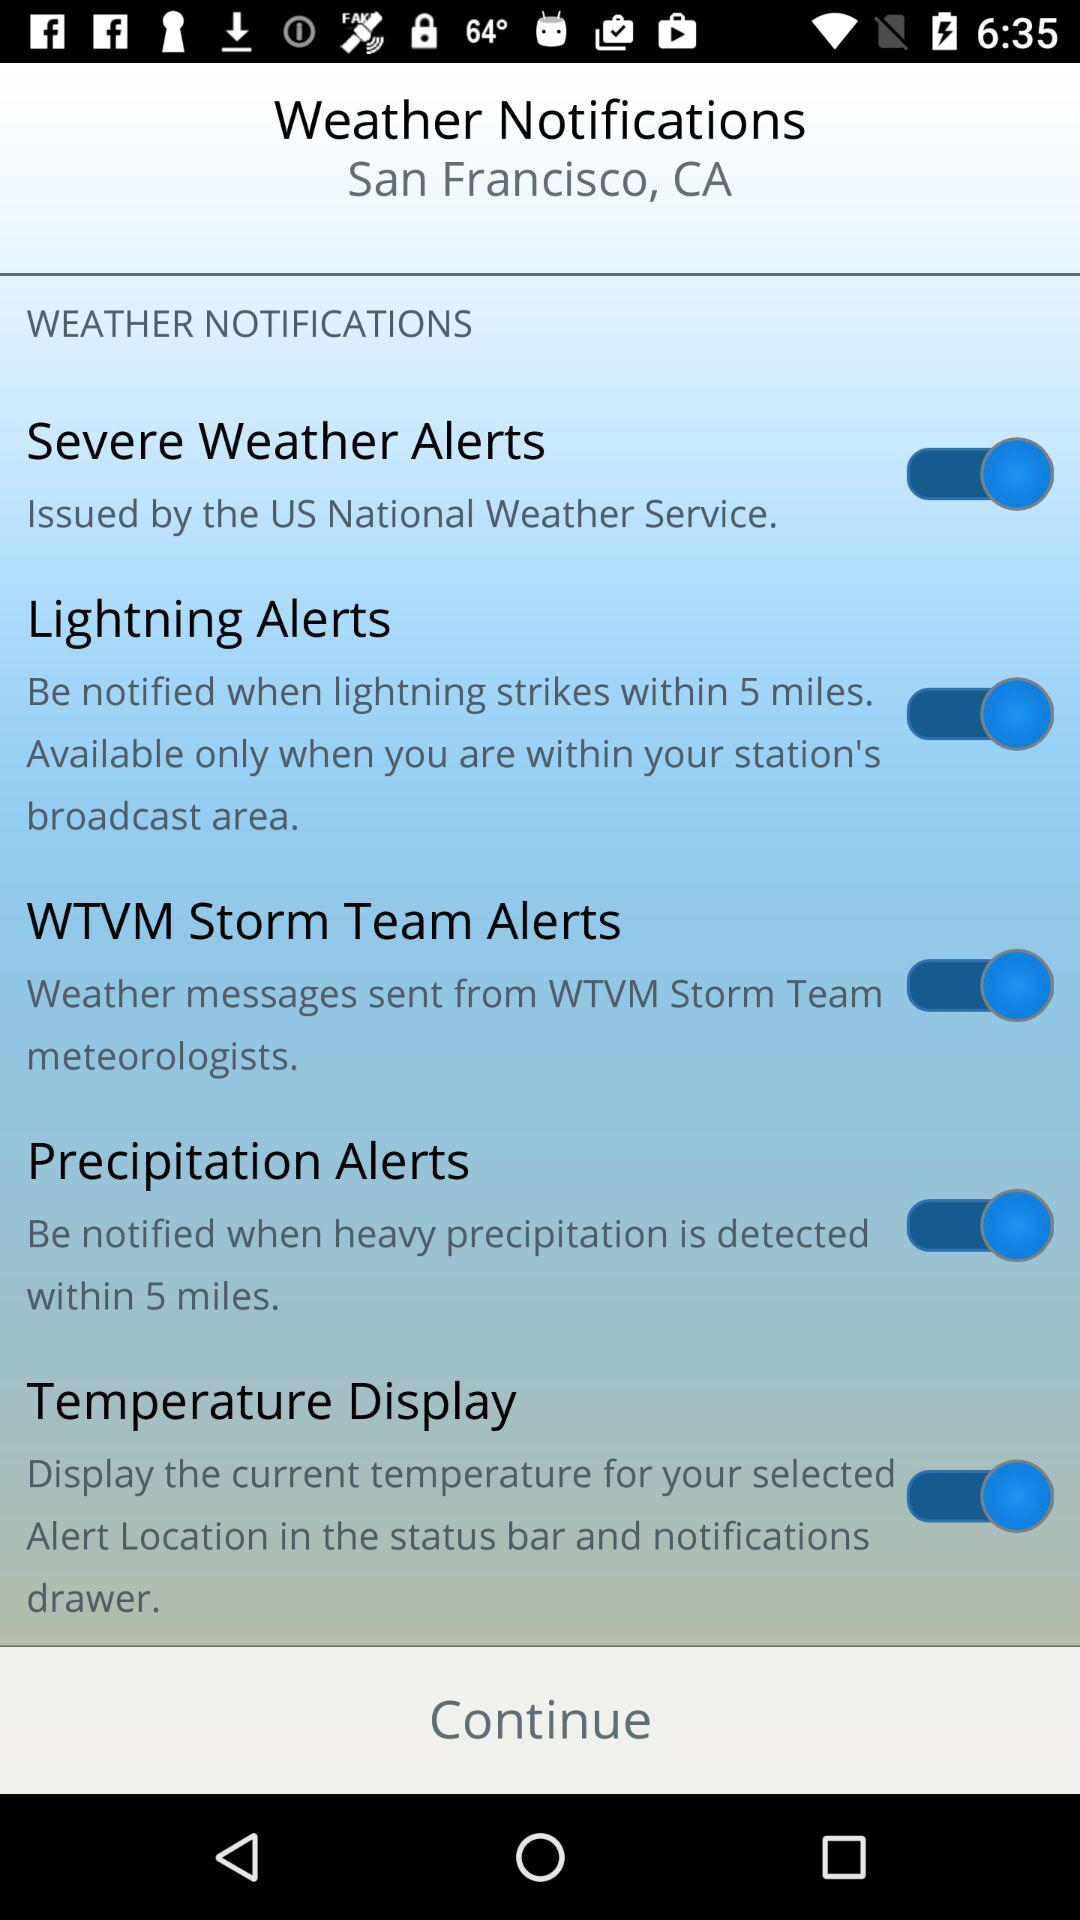Which weather notifications are "on"? The "on" weather notifications are "Severe Weather Alerts", "Lightning Alerts", "WTVM Storm Team Alerts", "Precipitation Alerts" and "Temperature Display". 